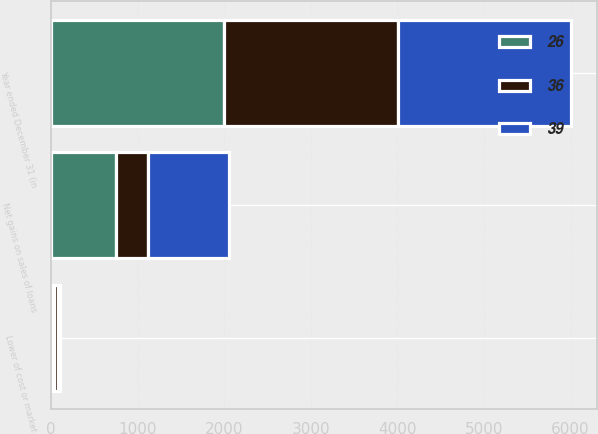Convert chart. <chart><loc_0><loc_0><loc_500><loc_500><stacked_bar_chart><ecel><fcel>Year ended December 31 (in<fcel>Net gains on sales of loans<fcel>Lower of cost or market<nl><fcel>36<fcel>2004<fcel>368<fcel>39<nl><fcel>39<fcel>2003<fcel>933<fcel>26<nl><fcel>26<fcel>2002<fcel>754<fcel>36<nl></chart> 